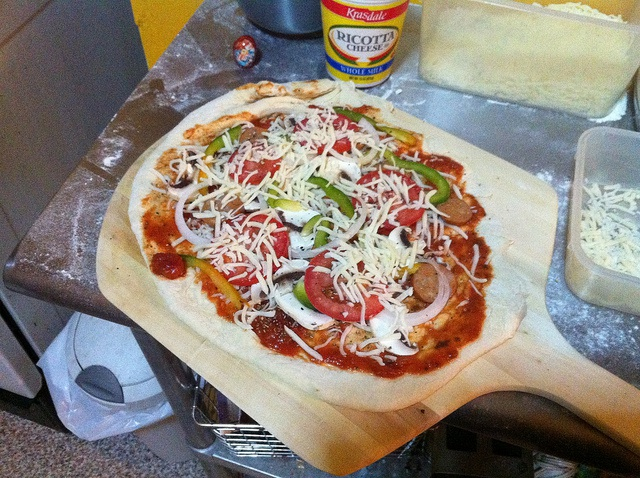Describe the objects in this image and their specific colors. I can see pizza in gray, lightgray, darkgray, and brown tones, refrigerator in gray and black tones, and bowl in gray, darkgray, lightgray, and lightblue tones in this image. 